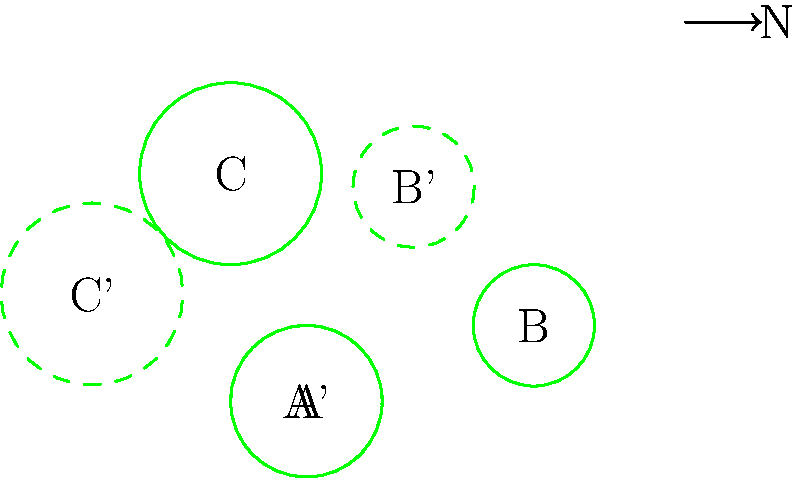The map shows three local parks (A, B, and C) in your new neighborhood. To align the map with cardinal directions, you need to rotate it clockwise. What is the angle of rotation needed to make park B directly east of park A? To solve this problem, we need to follow these steps:

1. Observe the original positions of parks A and B:
   - Park A is at (0,0)
   - Park B is at (3,1)

2. For B to be directly east of A, it should be on the same horizontal line as A after rotation.

3. Calculate the current angle between the line AB and the horizontal:
   - Using the arctangent function: $\theta = \arctan(\frac{y}{x}) = \arctan(\frac{1}{3})$
   - $\theta \approx 18.43^\circ$

4. To make AB horizontal, we need to rotate clockwise by this angle.

5. However, we want to align with cardinal directions (North at the top).
   - A clockwise rotation of 45° aligns the map with cardinal directions.

6. Therefore, the total rotation needed is:
   $45^\circ - 18.43^\circ = 26.57^\circ$

7. Rounding to the nearest degree: 27°
Answer: 27° 